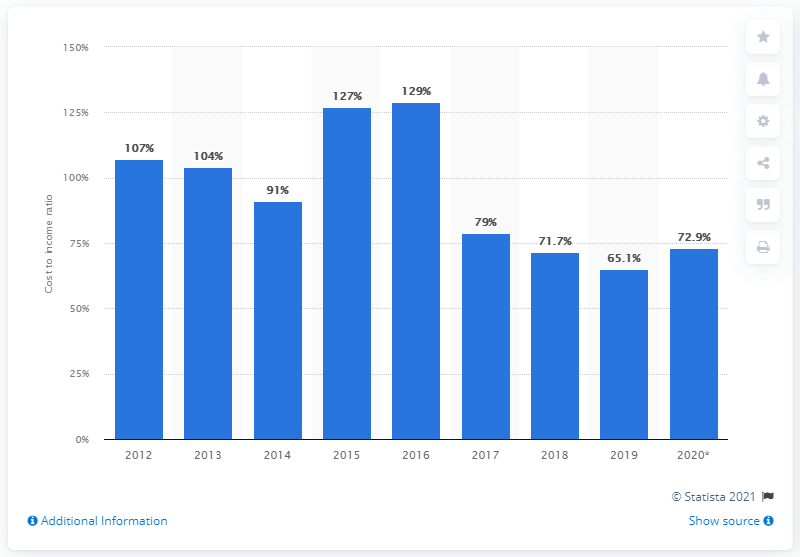Draw attention to some important aspects in this diagram. The cost to income ratio of Royal Bank of Scotland in 2020 was 72.9%. In 2016, the cost to income ratio of the NatWest group was 129%. 